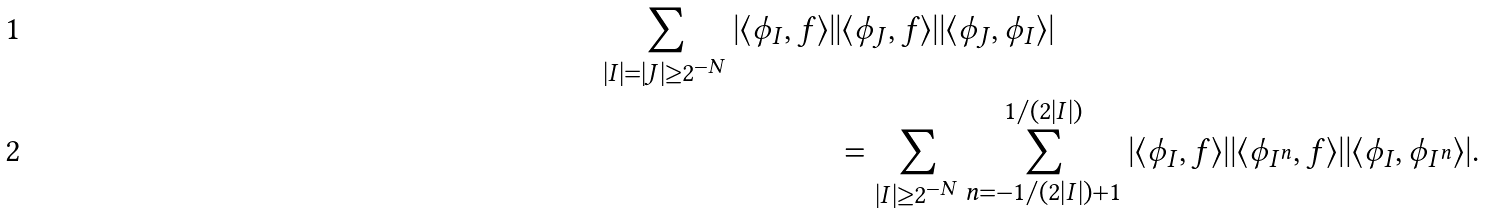Convert formula to latex. <formula><loc_0><loc_0><loc_500><loc_500>\sum _ { | I | = | J | \geq 2 ^ { - N } } | \langle \phi _ { I } , f \rangle | & | \langle \phi _ { J } , f \rangle | | \langle \phi _ { J } , \phi _ { I } \rangle | \\ & = \sum _ { | I | \geq 2 ^ { - N } } \sum _ { n = - 1 / ( 2 | I | ) + 1 } ^ { 1 / ( 2 | I | ) } | \langle \phi _ { I } , f \rangle | | \langle \phi _ { I ^ { n } } , f \rangle | | \langle \phi _ { I } , \phi _ { I ^ { n } } \rangle | .</formula> 